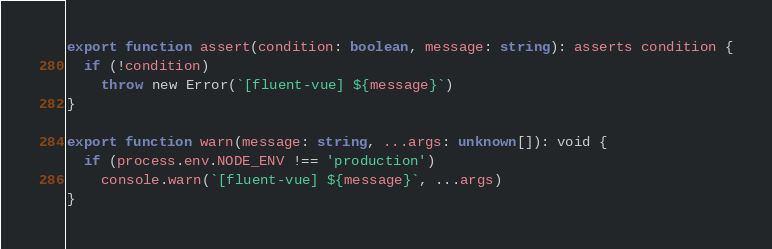<code> <loc_0><loc_0><loc_500><loc_500><_TypeScript_>export function assert(condition: boolean, message: string): asserts condition {
  if (!condition)
    throw new Error(`[fluent-vue] ${message}`)
}

export function warn(message: string, ...args: unknown[]): void {
  if (process.env.NODE_ENV !== 'production')
    console.warn(`[fluent-vue] ${message}`, ...args)
}
</code> 